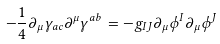<formula> <loc_0><loc_0><loc_500><loc_500>- \frac { 1 } { 4 } \partial _ { \mu } \gamma _ { a c } \partial ^ { \mu } \gamma ^ { a b } = - g _ { I J } \partial _ { \mu } \phi ^ { I } \partial _ { \mu } \phi ^ { J }</formula> 